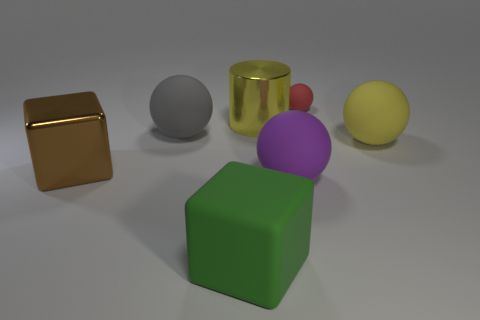Subtract all red rubber spheres. How many spheres are left? 3 Subtract all red balls. How many balls are left? 3 Add 6 big shiny cylinders. How many big shiny cylinders exist? 7 Add 1 tiny blue balls. How many objects exist? 8 Subtract 0 green cylinders. How many objects are left? 7 Subtract all balls. How many objects are left? 3 Subtract 2 cubes. How many cubes are left? 0 Subtract all gray balls. Subtract all brown cubes. How many balls are left? 3 Subtract all blue cubes. How many gray spheres are left? 1 Subtract all small brown rubber spheres. Subtract all large metallic blocks. How many objects are left? 6 